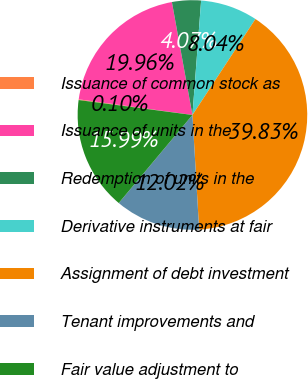Convert chart to OTSL. <chart><loc_0><loc_0><loc_500><loc_500><pie_chart><fcel>Issuance of common stock as<fcel>Issuance of units in the<fcel>Redemption of units in the<fcel>Derivative instruments at fair<fcel>Assignment of debt investment<fcel>Tenant improvements and<fcel>Fair value adjustment to<nl><fcel>0.1%<fcel>19.96%<fcel>4.07%<fcel>8.04%<fcel>39.83%<fcel>12.02%<fcel>15.99%<nl></chart> 